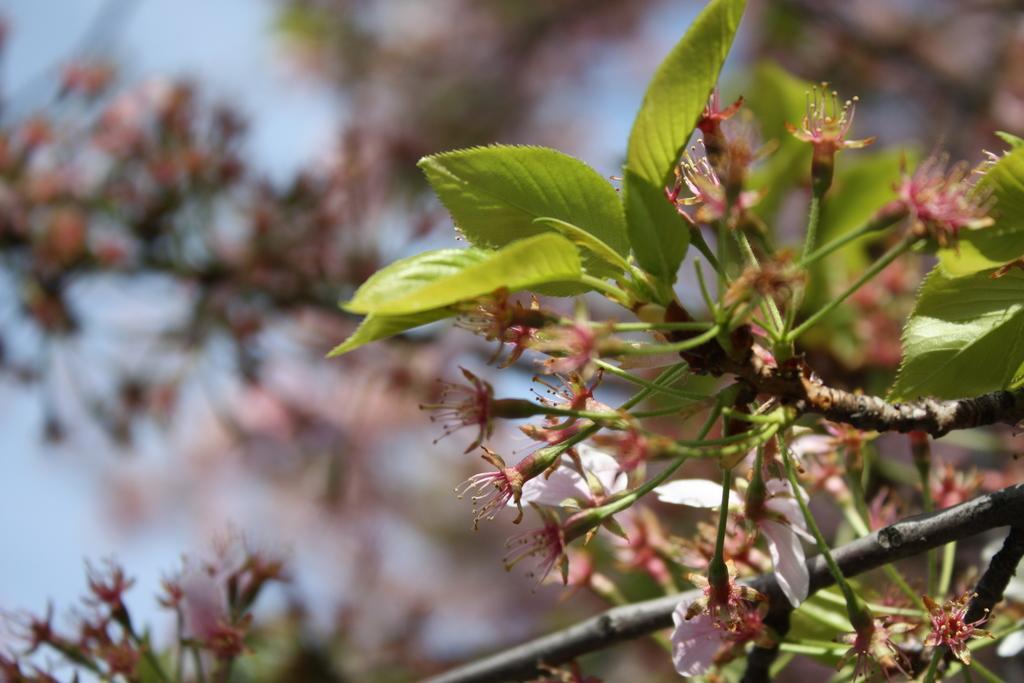How would you summarize this image in a sentence or two? In this image there are few plants having flowers and leaves. Background there is sky. 